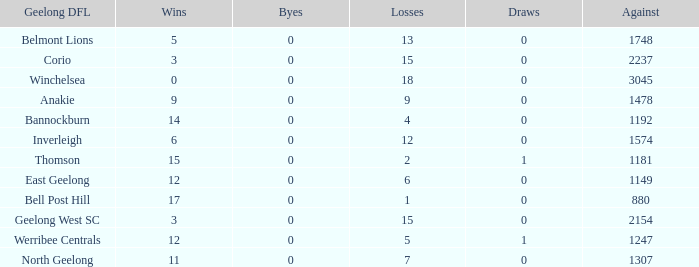In geelong dfl, when bell post hill has a negative number of draws, what is their average loss? None. 